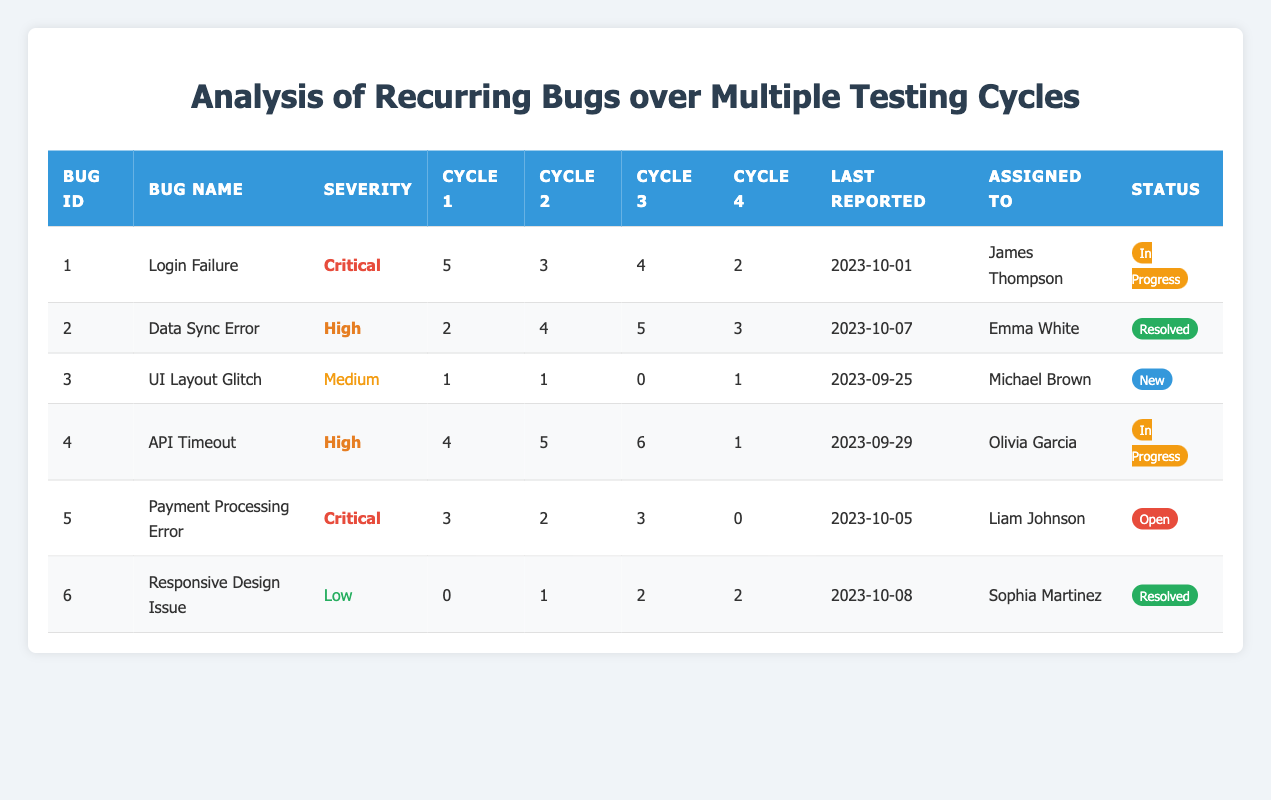What is the severity level of the "Payment Processing Error" bug? The "Payment Processing Error" bug is listed under the Severity column with the value "Critical."
Answer: Critical Who is assigned to fix the "API Timeout" bug? The "API Timeout" bug is assigned to "Olivia Garcia," as indicated in the Assigned To column.
Answer: Olivia Garcia How many times was the "Responsive Design Issue" reported over all cycles? The frequencies for the "Responsive Design Issue" across cycles are 0, 1, 2, and 2. Summing these gives 0 + 1 + 2 + 2 = 5.
Answer: 5 Which bug had the highest frequency in Cycle 3? The "API Timeout" bug had the highest frequency in Cycle 3, with a count of 6.
Answer: API Timeout Is the "UI Layout Glitch" currently resolved? The status of the "UI Layout Glitch" is listed as "New," which means it is not yet resolved.
Answer: No What is the average frequency of the "Login Failure" bug across all cycles? The frequencies for "Login Failure" across cycles are 5, 3, 4, and 2. The sum is 5 + 3 + 4 + 2 = 14. Since there are 4 cycles, the average is 14 / 4 = 3.5.
Answer: 3.5 Which bug shows a trend of decreasing frequency across the last three cycles? The "Login Failure" bug shows a decreasing trend with frequencies of 4, 3, and 2 in the last three cycles.
Answer: Login Failure What is the last reported date for the bug with the highest severity? The bug with the highest severity is "Login Failure," last reported on "2023-10-01."
Answer: 2023-10-01 How many unique bugs are categorized as "Critical" in the table? The table lists two bugs with "Critical" severity: "Login Failure" and "Payment Processing Error."
Answer: 2 What is the total frequency of the "Data Sync Error" bug across all cycles? The total frequency for the "Data Sync Error" bug is calculated from its occurrences: 2 + 4 + 5 + 3 = 14.
Answer: 14 